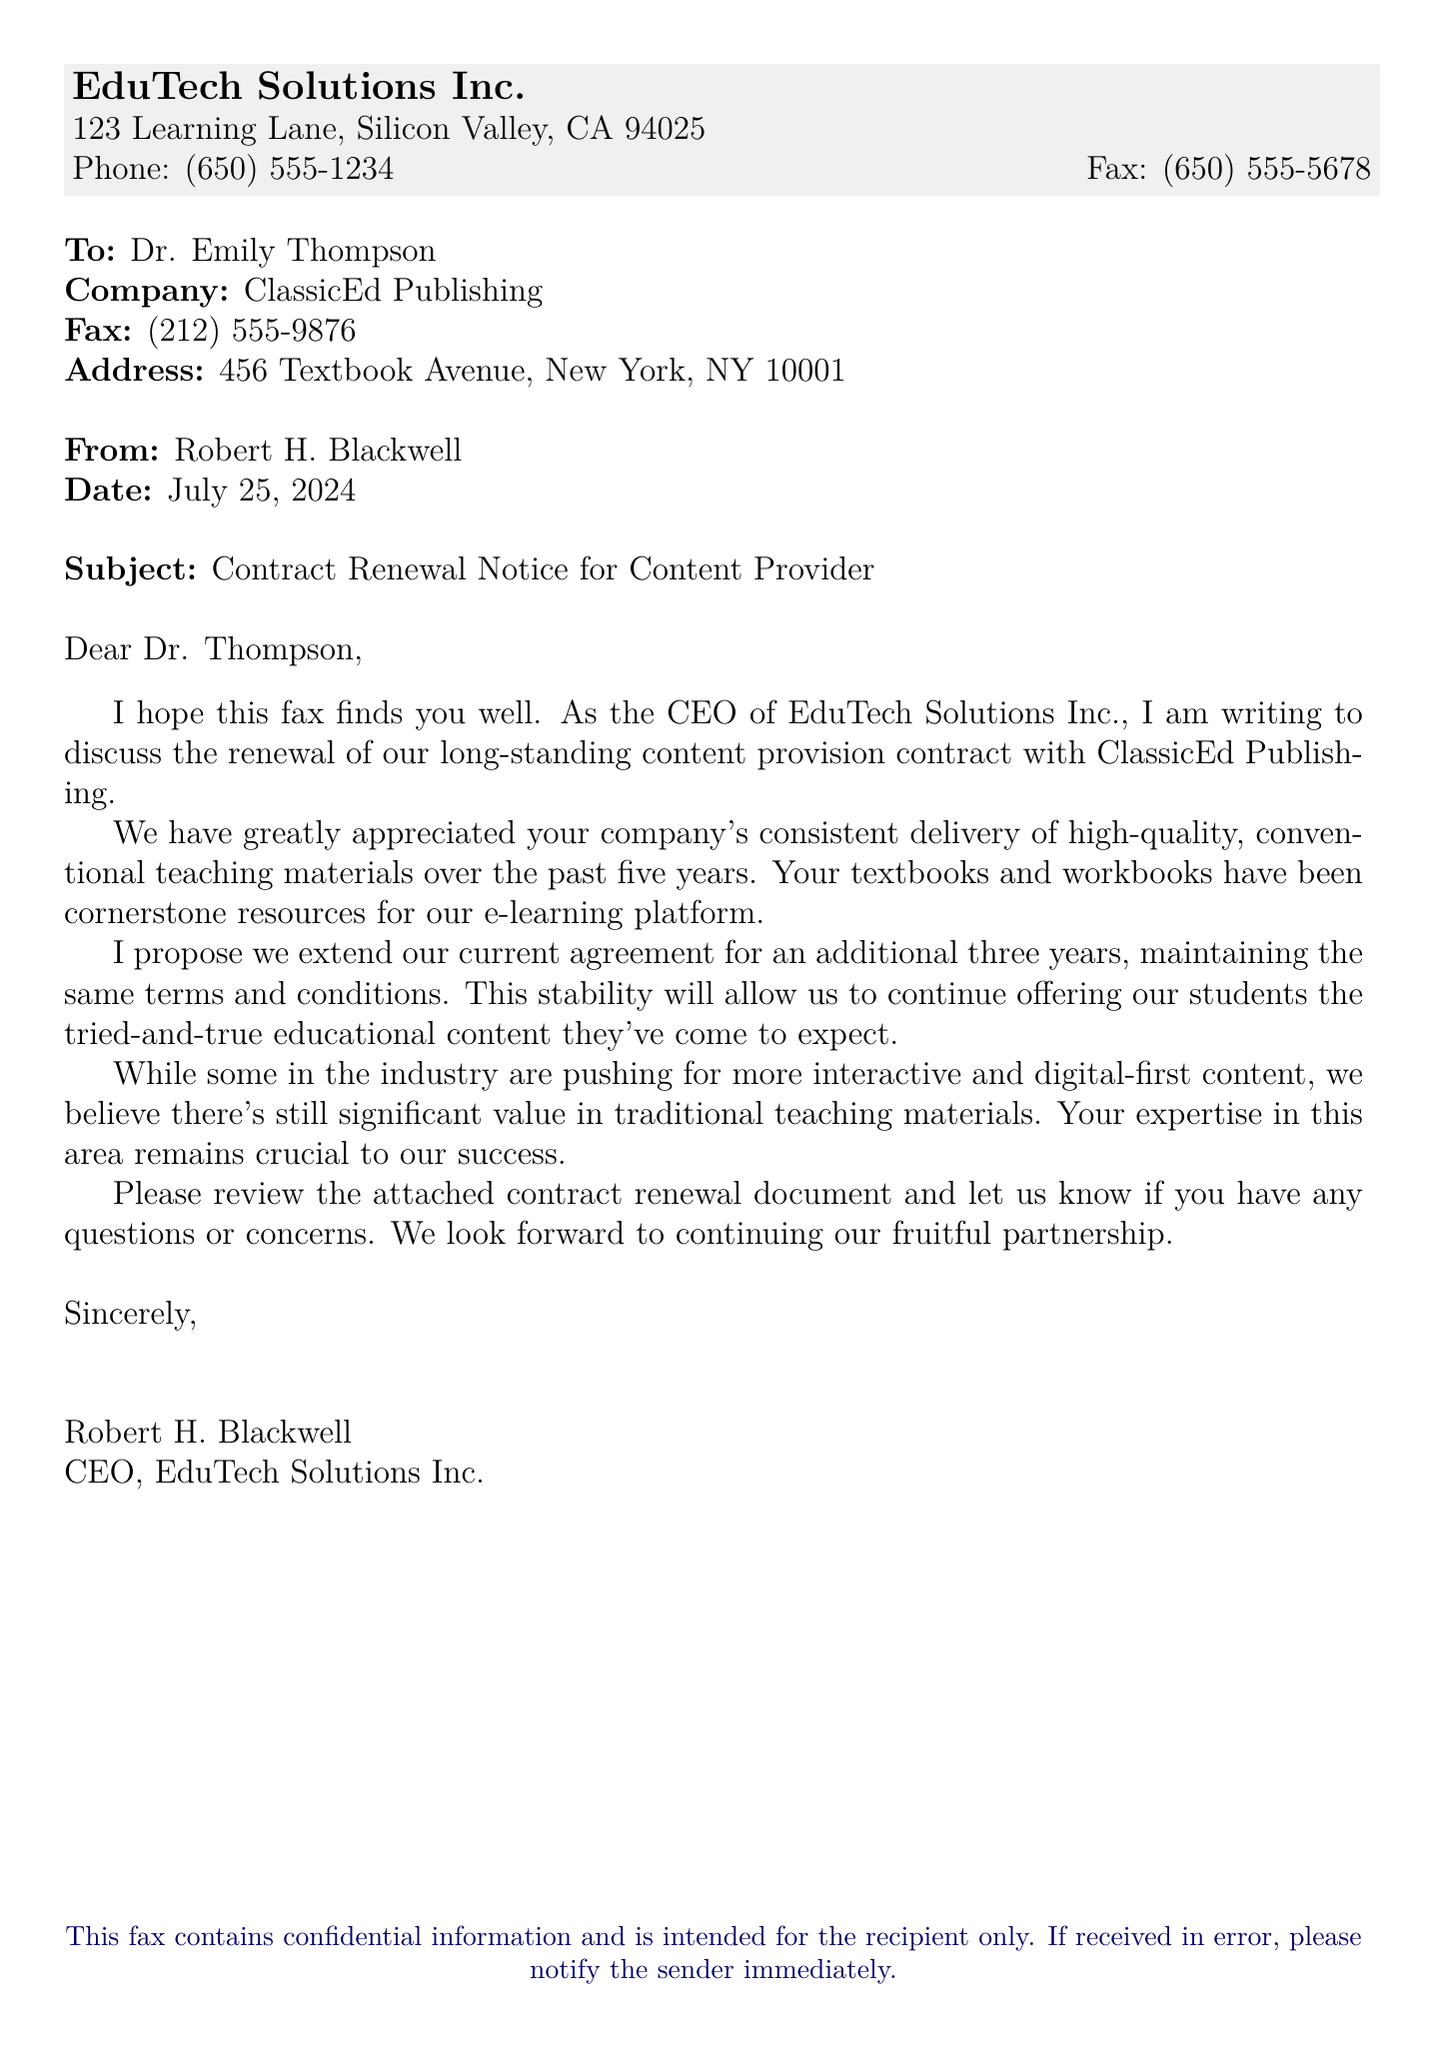What is the name of the sender? The sender's name is listed at the bottom of the document.
Answer: Robert H. Blackwell What is the subject of the fax? The subject is mentioned in the subject line of the fax.
Answer: Contract Renewal Notice for Content Provider Who is the recipient of the fax? The recipient's name is specified at the beginning of the document.
Answer: Dr. Emily Thompson What is the fax number of ClassicEd Publishing? The fax number for ClassicEd Publishing is provided in the contact details for the recipient.
Answer: (212) 555-9876 How long has EduTech Solutions Inc. worked with ClassicEd Publishing? The duration of the partnership is stated in the opening paragraph of the fax.
Answer: five years How many years is the proposed contract extension? The proposed contract extension period is mentioned in the document.
Answer: three years What type of materials does ClassicEd Publishing specialize in? The document describes the focus of ClassicEd Publishing in the introductory paragraph.
Answer: conventional teaching materials What is the address of EduTech Solutions Inc.? The address is given in the header section of the document.
Answer: 123 Learning Lane, Silicon Valley, CA 94025 Why does the sender believe in traditional teaching materials? The sender expresses a reasoning related to the market trends mentioned in the letters.
Answer: significant value 